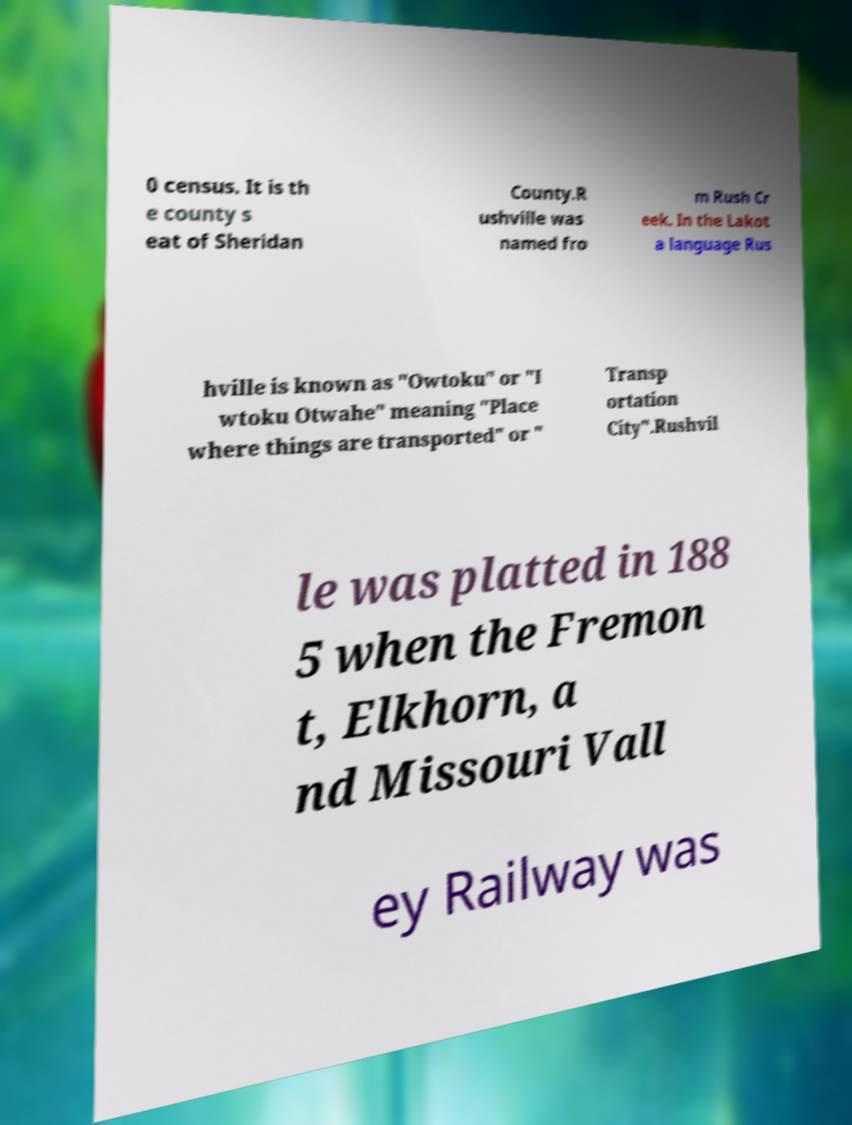What messages or text are displayed in this image? I need them in a readable, typed format. 0 census. It is th e county s eat of Sheridan County.R ushville was named fro m Rush Cr eek. In the Lakot a language Rus hville is known as "Owtoku" or "I wtoku Otwahe" meaning "Place where things are transported" or " Transp ortation City".Rushvil le was platted in 188 5 when the Fremon t, Elkhorn, a nd Missouri Vall ey Railway was 